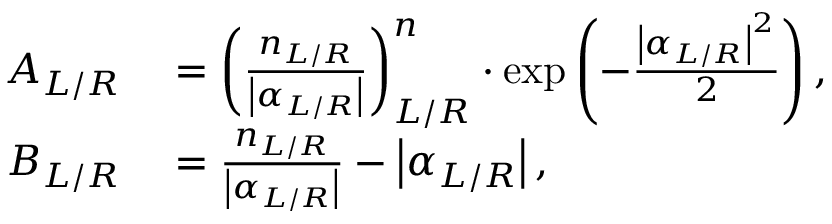Convert formula to latex. <formula><loc_0><loc_0><loc_500><loc_500>\begin{array} { r l } { A _ { L / R } } & = \left ( \frac { n _ { L / R } } { \left | \alpha _ { L / R } \right | } \right ) _ { L / R } ^ { n } \cdot \exp \left ( - \frac { \left | \alpha _ { L / R } \right | ^ { 2 } } { 2 } \right ) , } \\ { B _ { L / R } } & = \frac { n _ { L / R } } { \left | \alpha _ { L / R } \right | } - \left | \alpha _ { L / R } \right | , } \end{array}</formula> 